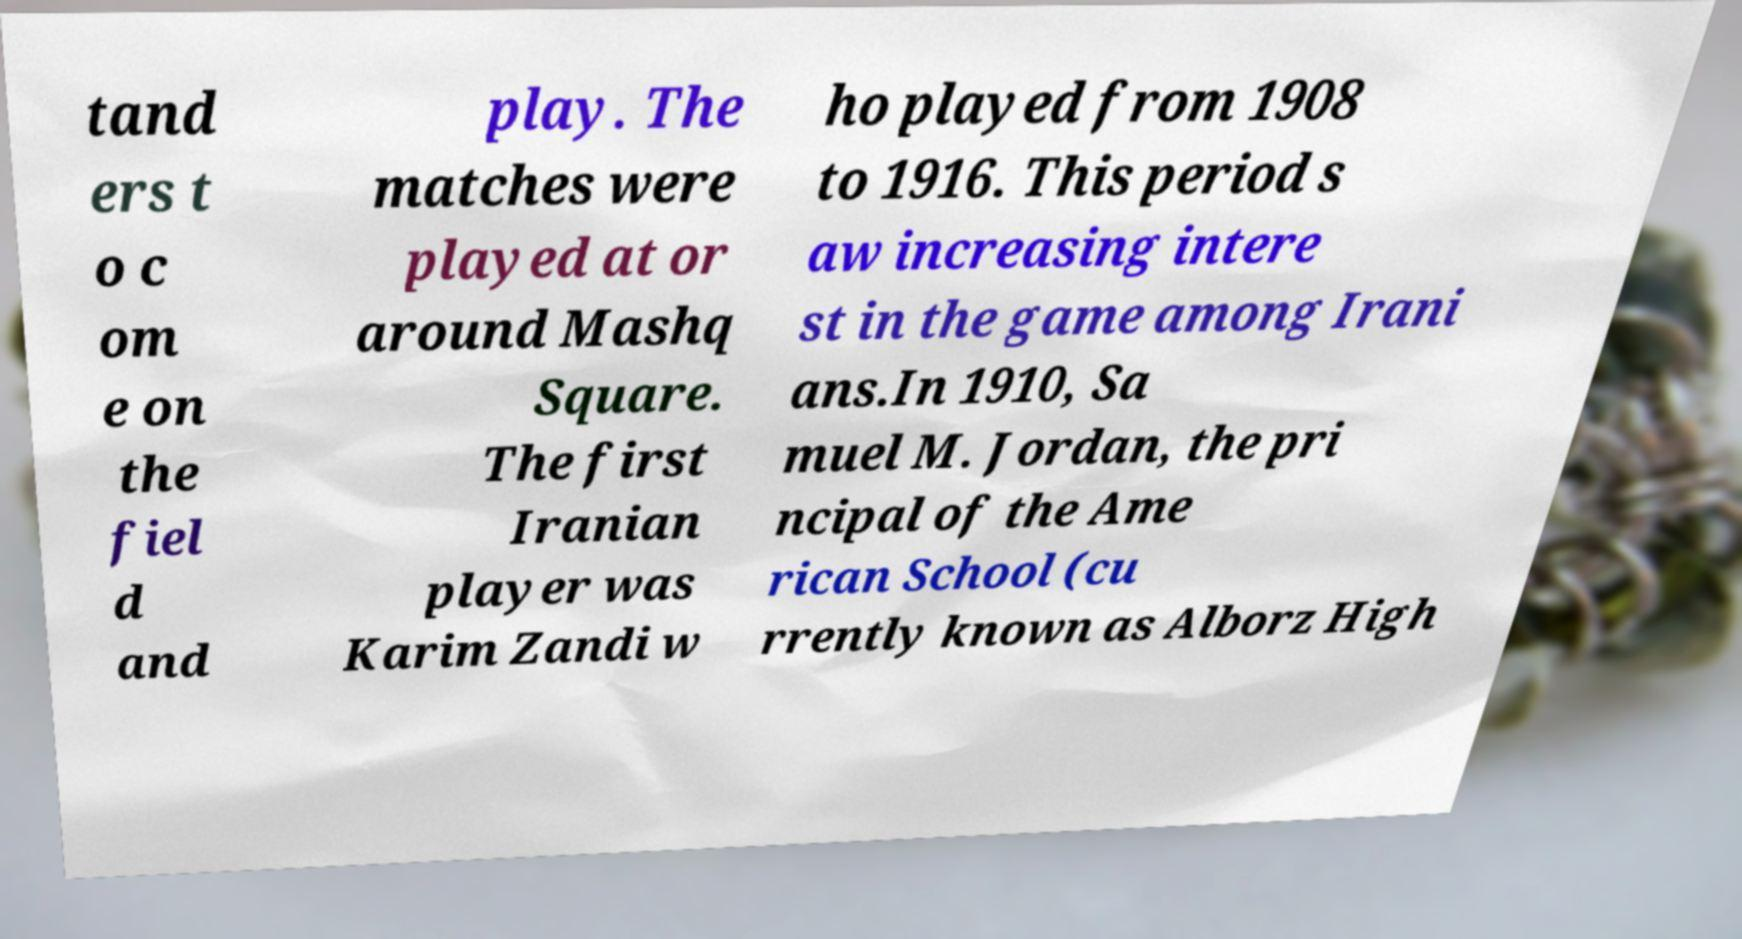Could you extract and type out the text from this image? tand ers t o c om e on the fiel d and play. The matches were played at or around Mashq Square. The first Iranian player was Karim Zandi w ho played from 1908 to 1916. This period s aw increasing intere st in the game among Irani ans.In 1910, Sa muel M. Jordan, the pri ncipal of the Ame rican School (cu rrently known as Alborz High 